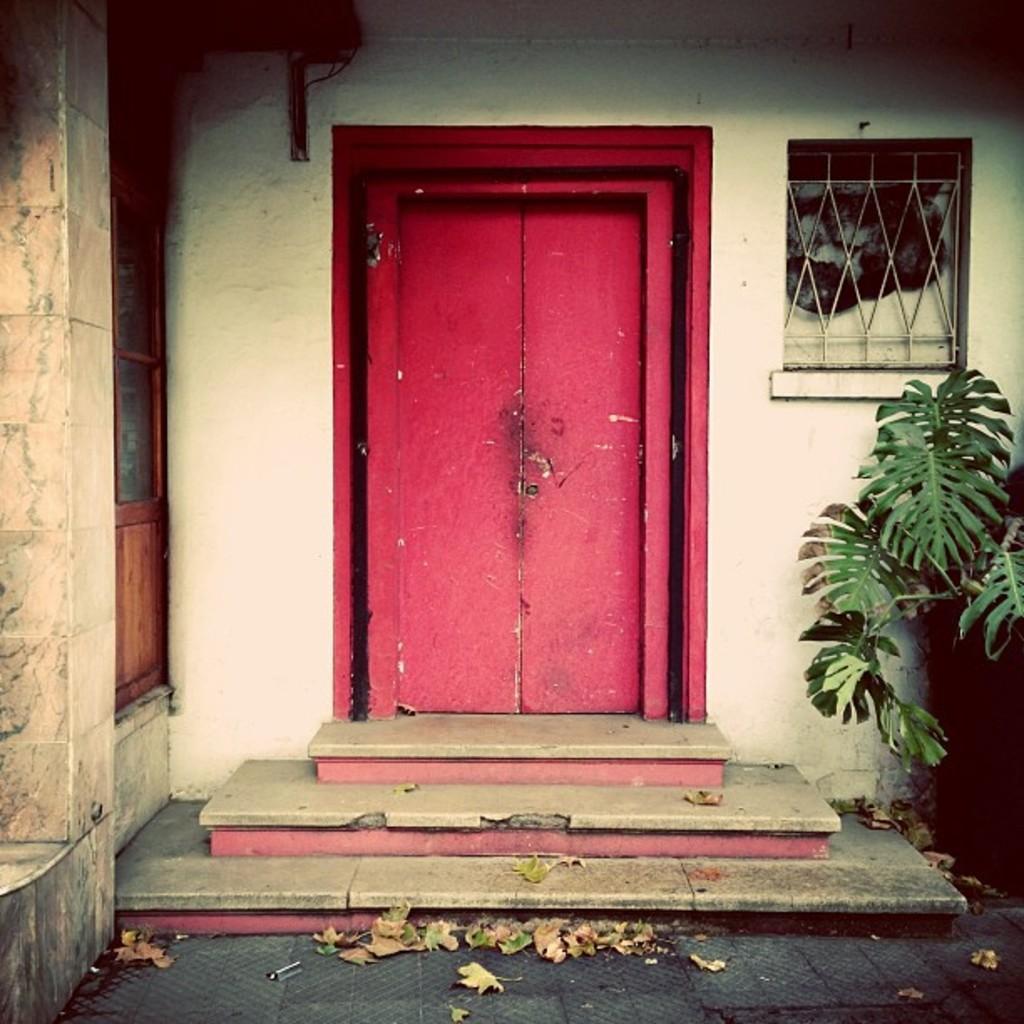In one or two sentences, can you explain what this image depicts? As we can see in the image there is a white color wall, door, window and a plant. 